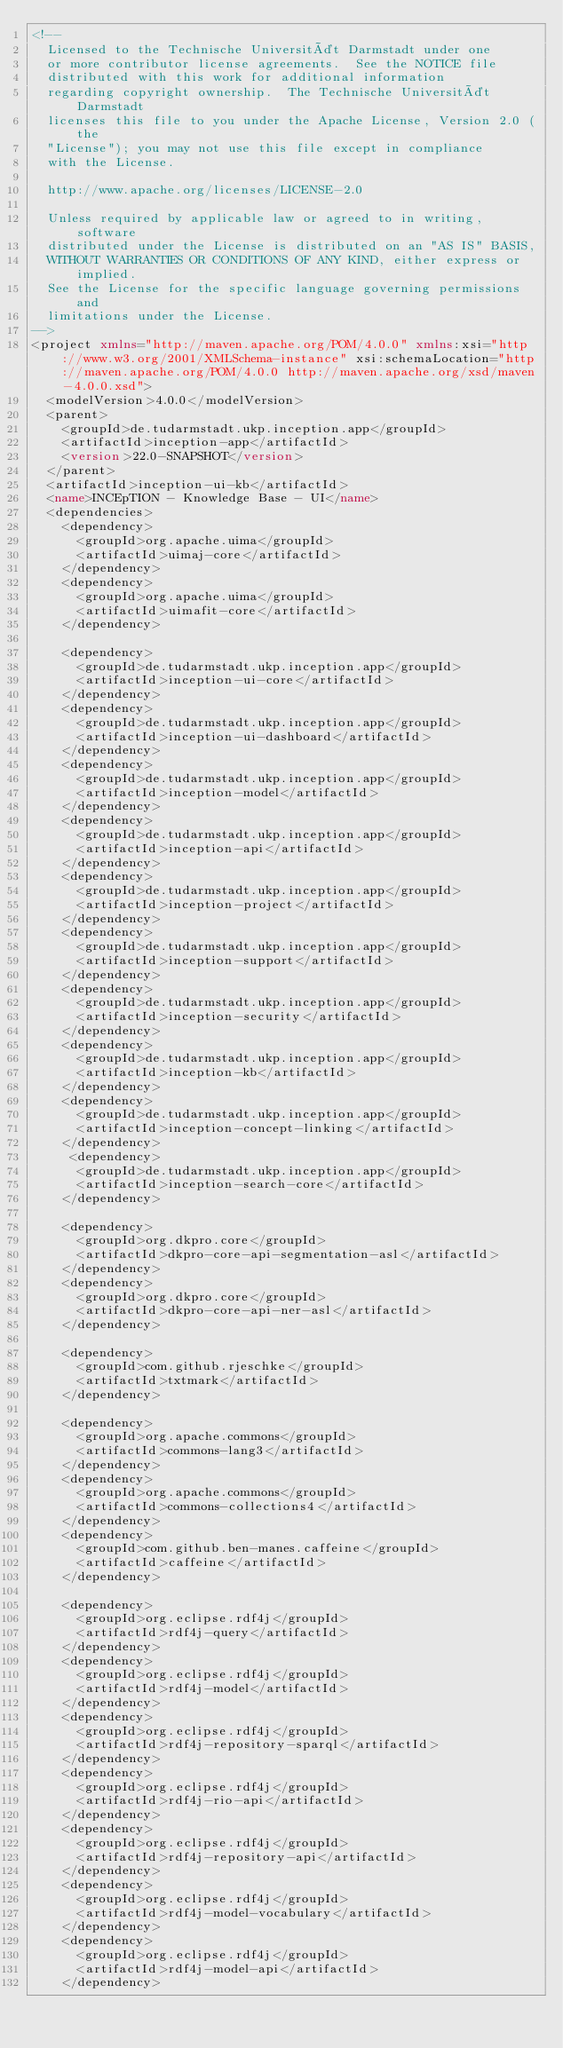<code> <loc_0><loc_0><loc_500><loc_500><_XML_><!--
  Licensed to the Technische Universität Darmstadt under one
  or more contributor license agreements.  See the NOTICE file
  distributed with this work for additional information
  regarding copyright ownership.  The Technische Universität Darmstadt 
  licenses this file to you under the Apache License, Version 2.0 (the
  "License"); you may not use this file except in compliance
  with the License.
   
  http://www.apache.org/licenses/LICENSE-2.0
  
  Unless required by applicable law or agreed to in writing, software
  distributed under the License is distributed on an "AS IS" BASIS,
  WITHOUT WARRANTIES OR CONDITIONS OF ANY KIND, either express or implied.
  See the License for the specific language governing permissions and
  limitations under the License.
-->
<project xmlns="http://maven.apache.org/POM/4.0.0" xmlns:xsi="http://www.w3.org/2001/XMLSchema-instance" xsi:schemaLocation="http://maven.apache.org/POM/4.0.0 http://maven.apache.org/xsd/maven-4.0.0.xsd">
  <modelVersion>4.0.0</modelVersion>
  <parent>
    <groupId>de.tudarmstadt.ukp.inception.app</groupId>
    <artifactId>inception-app</artifactId>
    <version>22.0-SNAPSHOT</version>
  </parent>
  <artifactId>inception-ui-kb</artifactId>
  <name>INCEpTION - Knowledge Base - UI</name>
  <dependencies>
    <dependency>
      <groupId>org.apache.uima</groupId>
      <artifactId>uimaj-core</artifactId>
    </dependency>
    <dependency>
      <groupId>org.apache.uima</groupId>
      <artifactId>uimafit-core</artifactId>
    </dependency>
    
    <dependency>
      <groupId>de.tudarmstadt.ukp.inception.app</groupId>
      <artifactId>inception-ui-core</artifactId>
    </dependency>
    <dependency>
      <groupId>de.tudarmstadt.ukp.inception.app</groupId>
      <artifactId>inception-ui-dashboard</artifactId>
    </dependency>
    <dependency>
      <groupId>de.tudarmstadt.ukp.inception.app</groupId>
      <artifactId>inception-model</artifactId>
    </dependency>
    <dependency>
      <groupId>de.tudarmstadt.ukp.inception.app</groupId>
      <artifactId>inception-api</artifactId>
    </dependency>
    <dependency>
      <groupId>de.tudarmstadt.ukp.inception.app</groupId>
      <artifactId>inception-project</artifactId>
    </dependency>
    <dependency>
      <groupId>de.tudarmstadt.ukp.inception.app</groupId>
      <artifactId>inception-support</artifactId>
    </dependency>
    <dependency>
      <groupId>de.tudarmstadt.ukp.inception.app</groupId>
      <artifactId>inception-security</artifactId>
    </dependency>
    <dependency>
      <groupId>de.tudarmstadt.ukp.inception.app</groupId>
      <artifactId>inception-kb</artifactId>
    </dependency>
    <dependency>
      <groupId>de.tudarmstadt.ukp.inception.app</groupId>
      <artifactId>inception-concept-linking</artifactId>
    </dependency>
     <dependency>
      <groupId>de.tudarmstadt.ukp.inception.app</groupId>
      <artifactId>inception-search-core</artifactId>
    </dependency>
    
    <dependency>
      <groupId>org.dkpro.core</groupId>
      <artifactId>dkpro-core-api-segmentation-asl</artifactId>
    </dependency>
    <dependency>
      <groupId>org.dkpro.core</groupId>
      <artifactId>dkpro-core-api-ner-asl</artifactId>
    </dependency>

    <dependency>
      <groupId>com.github.rjeschke</groupId>
      <artifactId>txtmark</artifactId>
    </dependency>

    <dependency>
      <groupId>org.apache.commons</groupId>
      <artifactId>commons-lang3</artifactId>
    </dependency>
    <dependency>
      <groupId>org.apache.commons</groupId>
      <artifactId>commons-collections4</artifactId>
    </dependency>
    <dependency>
      <groupId>com.github.ben-manes.caffeine</groupId>
      <artifactId>caffeine</artifactId>
    </dependency>

    <dependency>
      <groupId>org.eclipse.rdf4j</groupId>
      <artifactId>rdf4j-query</artifactId>
    </dependency>
    <dependency>
      <groupId>org.eclipse.rdf4j</groupId>
      <artifactId>rdf4j-model</artifactId>
    </dependency>
    <dependency>
      <groupId>org.eclipse.rdf4j</groupId>
      <artifactId>rdf4j-repository-sparql</artifactId>
    </dependency>
    <dependency>
      <groupId>org.eclipse.rdf4j</groupId>
      <artifactId>rdf4j-rio-api</artifactId>
    </dependency>
    <dependency>
      <groupId>org.eclipse.rdf4j</groupId>
      <artifactId>rdf4j-repository-api</artifactId>
    </dependency>
    <dependency>
      <groupId>org.eclipse.rdf4j</groupId>
      <artifactId>rdf4j-model-vocabulary</artifactId>
    </dependency>
    <dependency>
      <groupId>org.eclipse.rdf4j</groupId>
      <artifactId>rdf4j-model-api</artifactId>
    </dependency></code> 